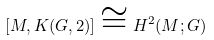<formula> <loc_0><loc_0><loc_500><loc_500>[ M , K ( G , 2 ) ] \cong H ^ { 2 } ( M ; G )</formula> 